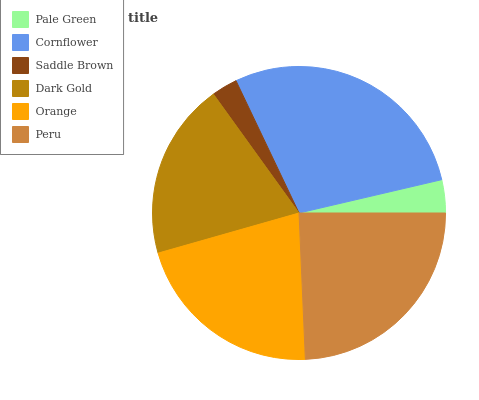Is Saddle Brown the minimum?
Answer yes or no. Yes. Is Cornflower the maximum?
Answer yes or no. Yes. Is Cornflower the minimum?
Answer yes or no. No. Is Saddle Brown the maximum?
Answer yes or no. No. Is Cornflower greater than Saddle Brown?
Answer yes or no. Yes. Is Saddle Brown less than Cornflower?
Answer yes or no. Yes. Is Saddle Brown greater than Cornflower?
Answer yes or no. No. Is Cornflower less than Saddle Brown?
Answer yes or no. No. Is Orange the high median?
Answer yes or no. Yes. Is Dark Gold the low median?
Answer yes or no. Yes. Is Peru the high median?
Answer yes or no. No. Is Saddle Brown the low median?
Answer yes or no. No. 